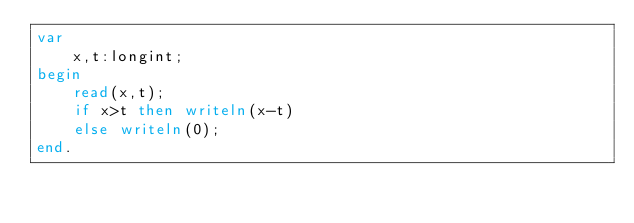<code> <loc_0><loc_0><loc_500><loc_500><_Pascal_>var
    x,t:longint;
begin
    read(x,t);
    if x>t then writeln(x-t)
    else writeln(0);
end.</code> 